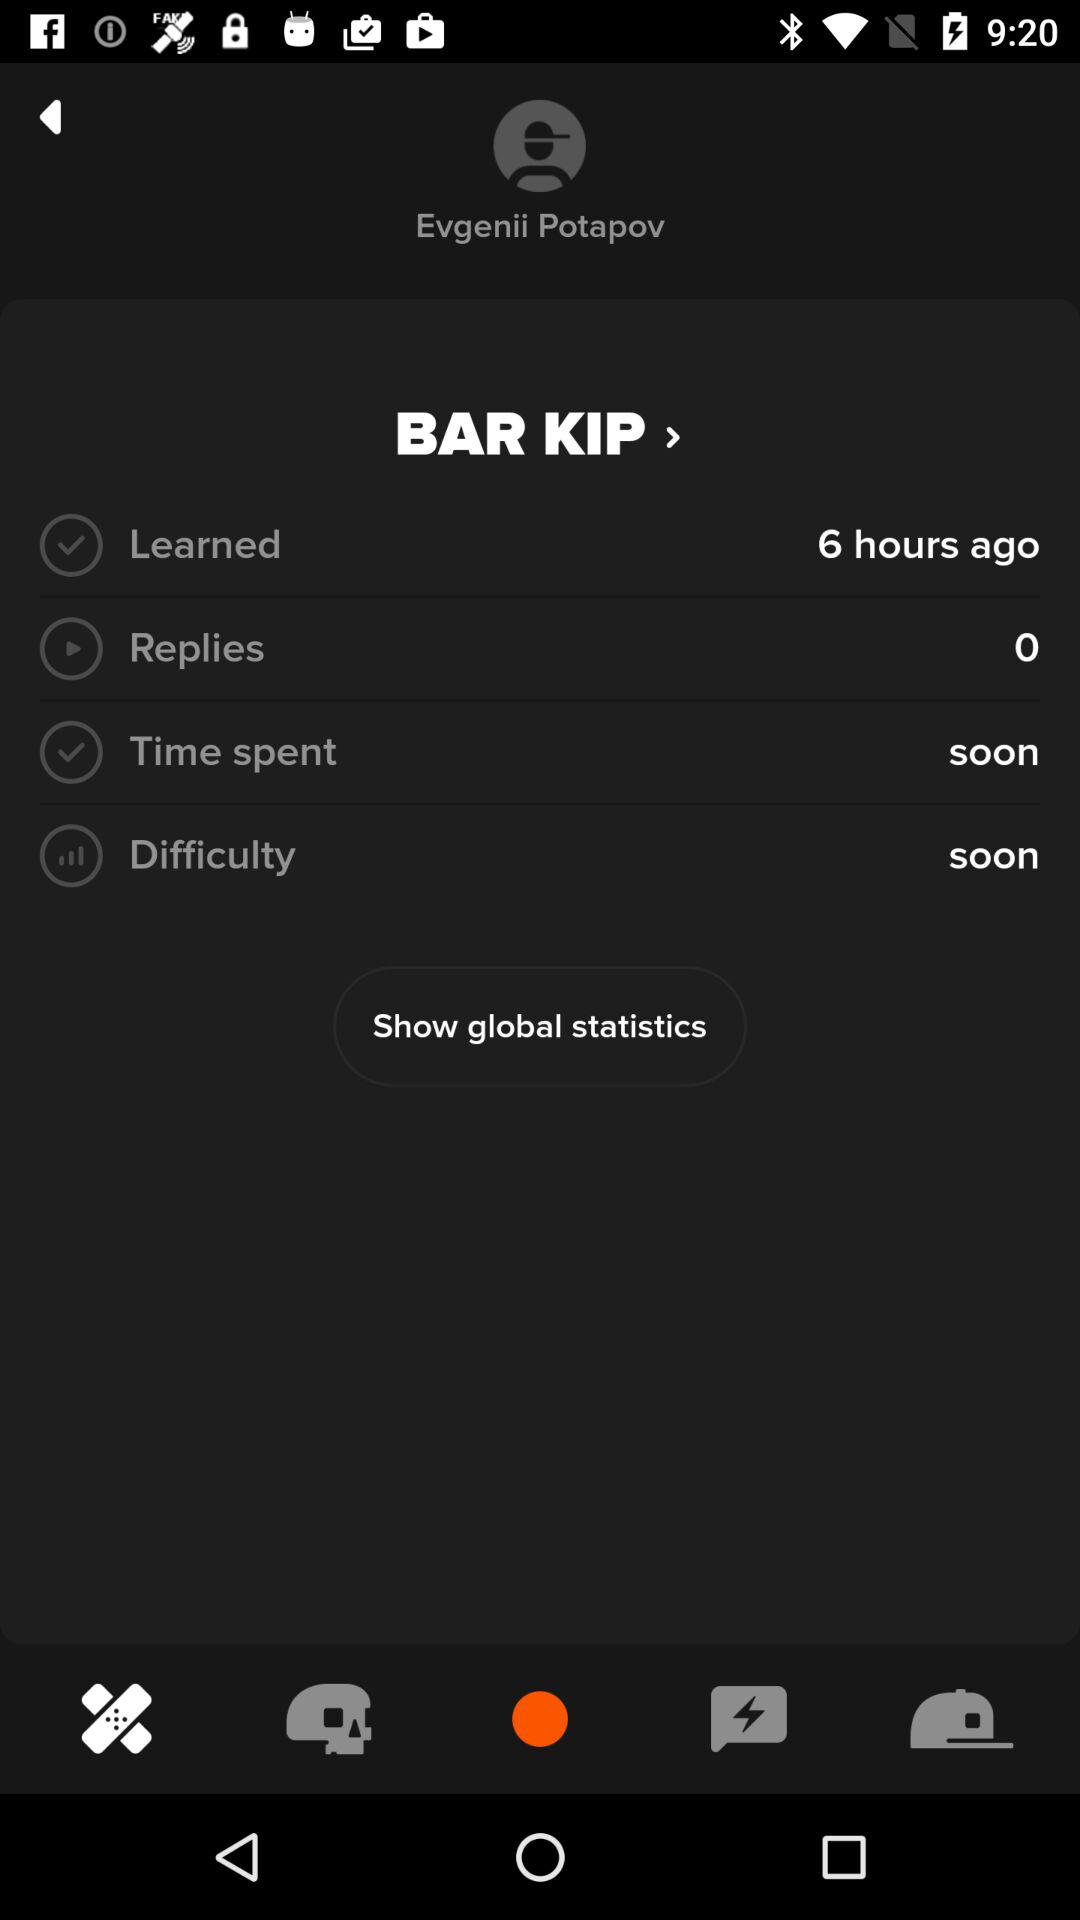How many replies are there? There are 0 replies. 